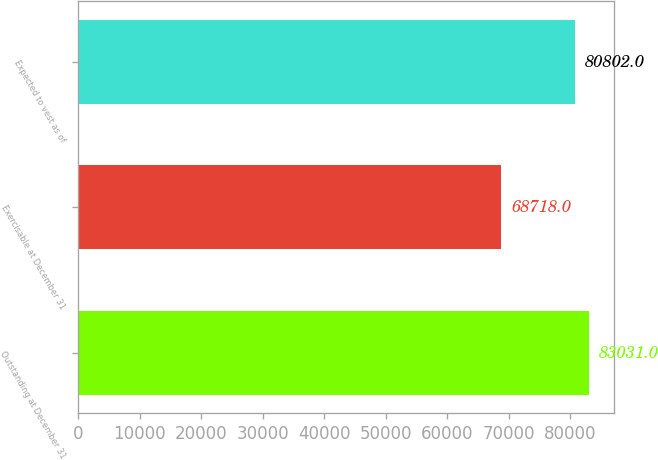Convert chart to OTSL. <chart><loc_0><loc_0><loc_500><loc_500><bar_chart><fcel>Outstanding at December 31<fcel>Exercisable at December 31<fcel>Expected to vest as of<nl><fcel>83031<fcel>68718<fcel>80802<nl></chart> 